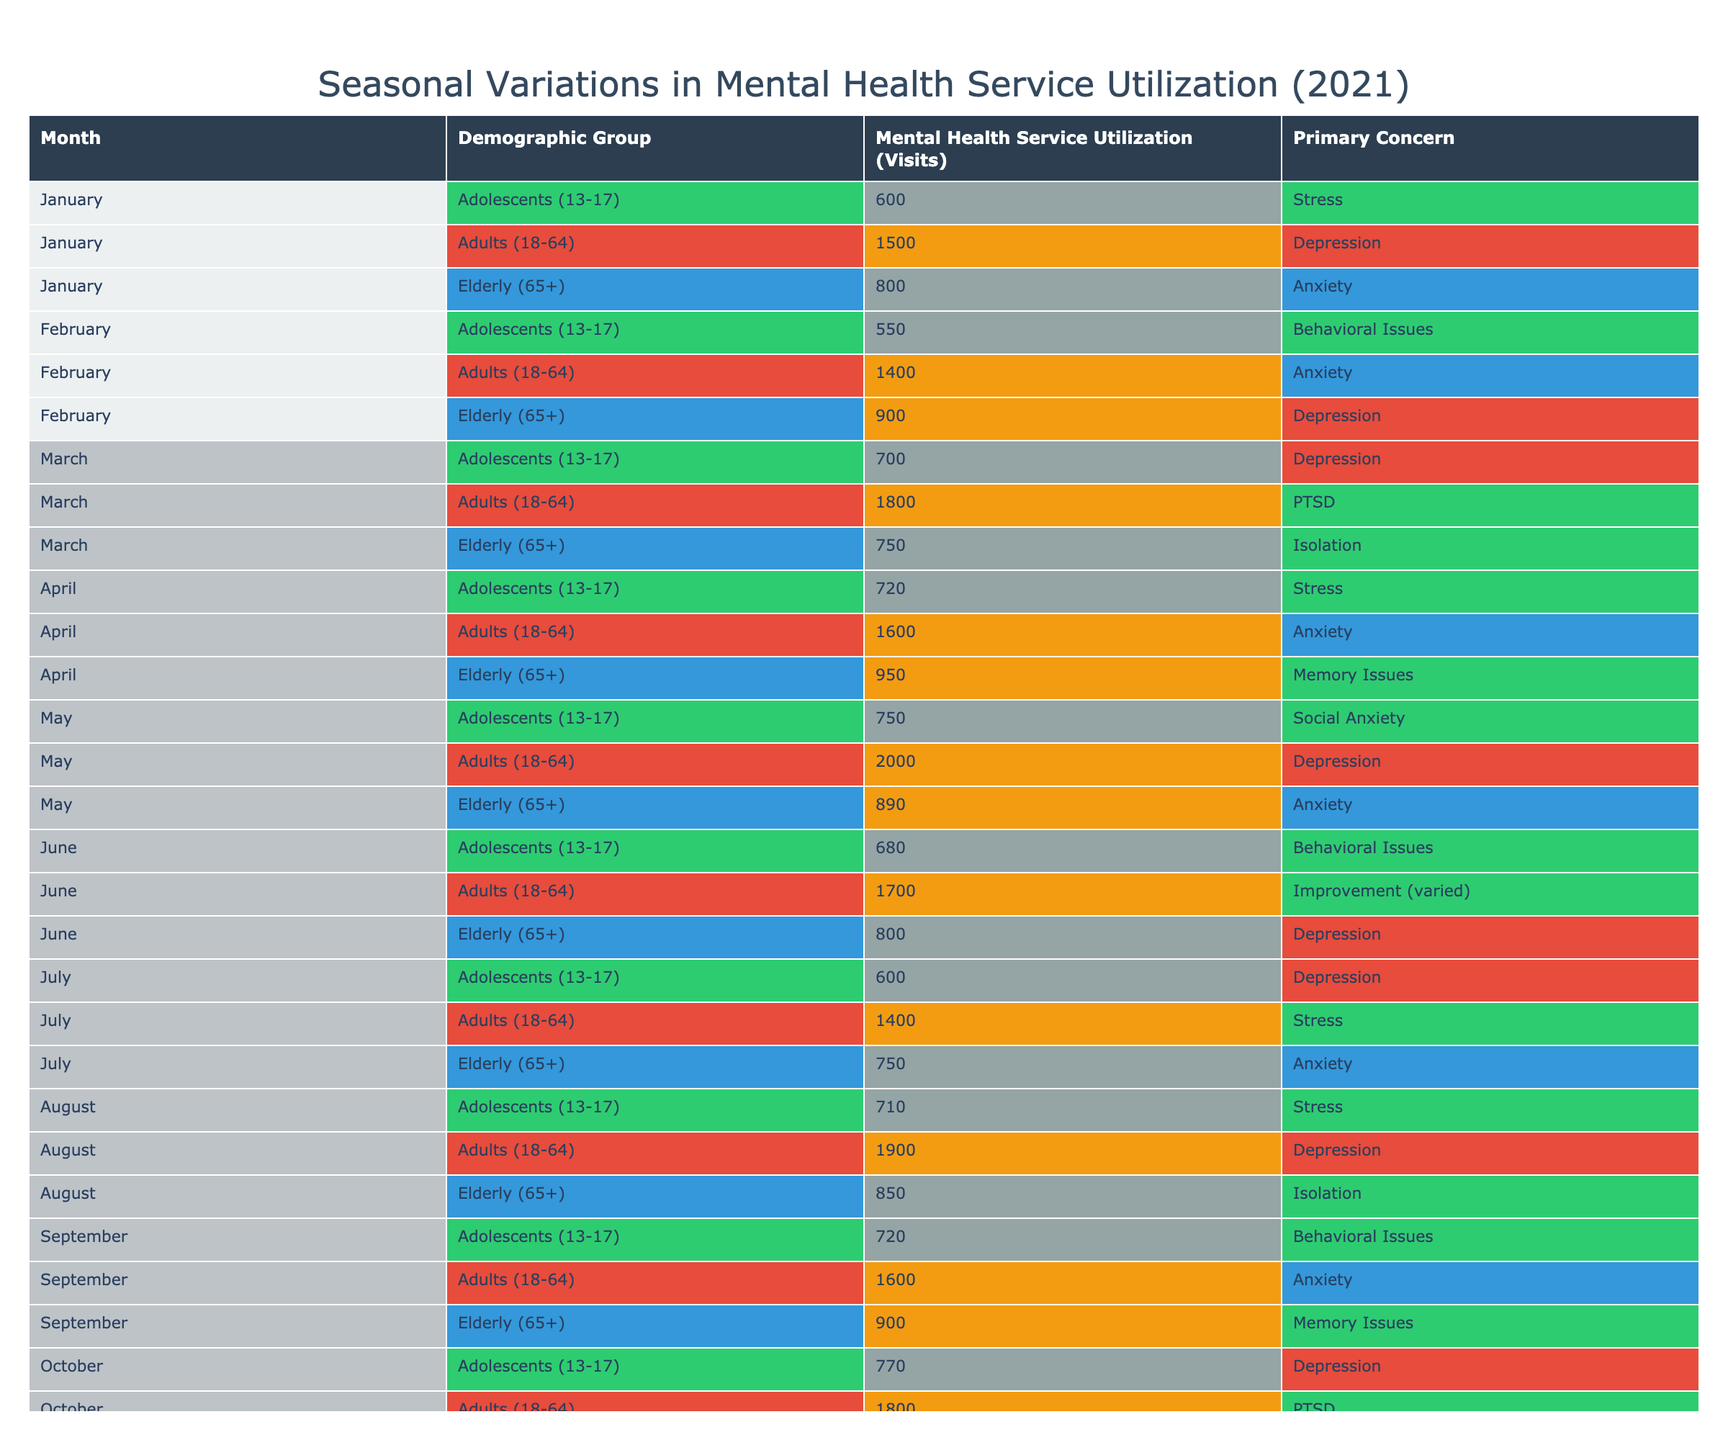What was the total mental health service utilization for adolescents in November? In November, the mental health service utilization for adolescents is listed as 650 visits. Since there is only one entry for November concerning this demographic, the total is simply 650.
Answer: 650 What primary concern had the highest utilization in the month of May for adults? In May, adults had varying primary concerns across visits, with the highest being Depression at 2000 visits. This is confirmed by checking the respective entry for adults in May.
Answer: Depression Did the elderly demographic have more visits for anxiety in October than in February? In October, the elderly demographic had 950 visits for anxiety, while in February, they had 900 visits. Since 950 is greater than 900, the answer is yes.
Answer: Yes What is the difference in mental health service utilization visits between adults in December and adolescents in January? Adults in December had 2200 visits and adolescents in January had 600 visits. To find the difference, we calculate 2200 - 600 = 1600. Therefore, the difference in visits is 1600.
Answer: 1600 Which month saw the greatest number of mental health service visits for the elderly demographic? By examining the table, we can check each month's visit counts for the elderly. The highest number is in December with 1000 visits. Therefore, December had the most visits for the elderly.
Answer: December What was the total mental health service utilization for all demographics combined in March? For March, we can sum all the visits across the three demographic groups: Adults (1800), Elderly (750), and Adolescents (700). Adding these gives us 1800 + 750 + 700 = 3250.
Answer: 3250 In which month did the adolescents exhibit the highest number of visits for stress? By looking at the data for adolescents, the monthly visits for stress are noted as follows: January (600), April (720), August (710), and November (650). The highest was in April with 720 visits.
Answer: April Was there any month where the elderly had more visits for memory issues than for anxiety? The elderly utilized services for memory issues in April (950 visits) and September (900 visits), but only for anxiety in February (900 visits) and October (950 visits). Summing these, there is no month where memory issues went over these thresholds. Thus, the answer is no.
Answer: No How many visits did adolescents have for behavioral issues in total throughout the year? The visits for adolescents concerning behavioral issues were as follows: February (550), June (680), September (720), and December (800). Adding these gives us 550 + 680 + 720 + 800 = 2750 visits in total.
Answer: 2750 